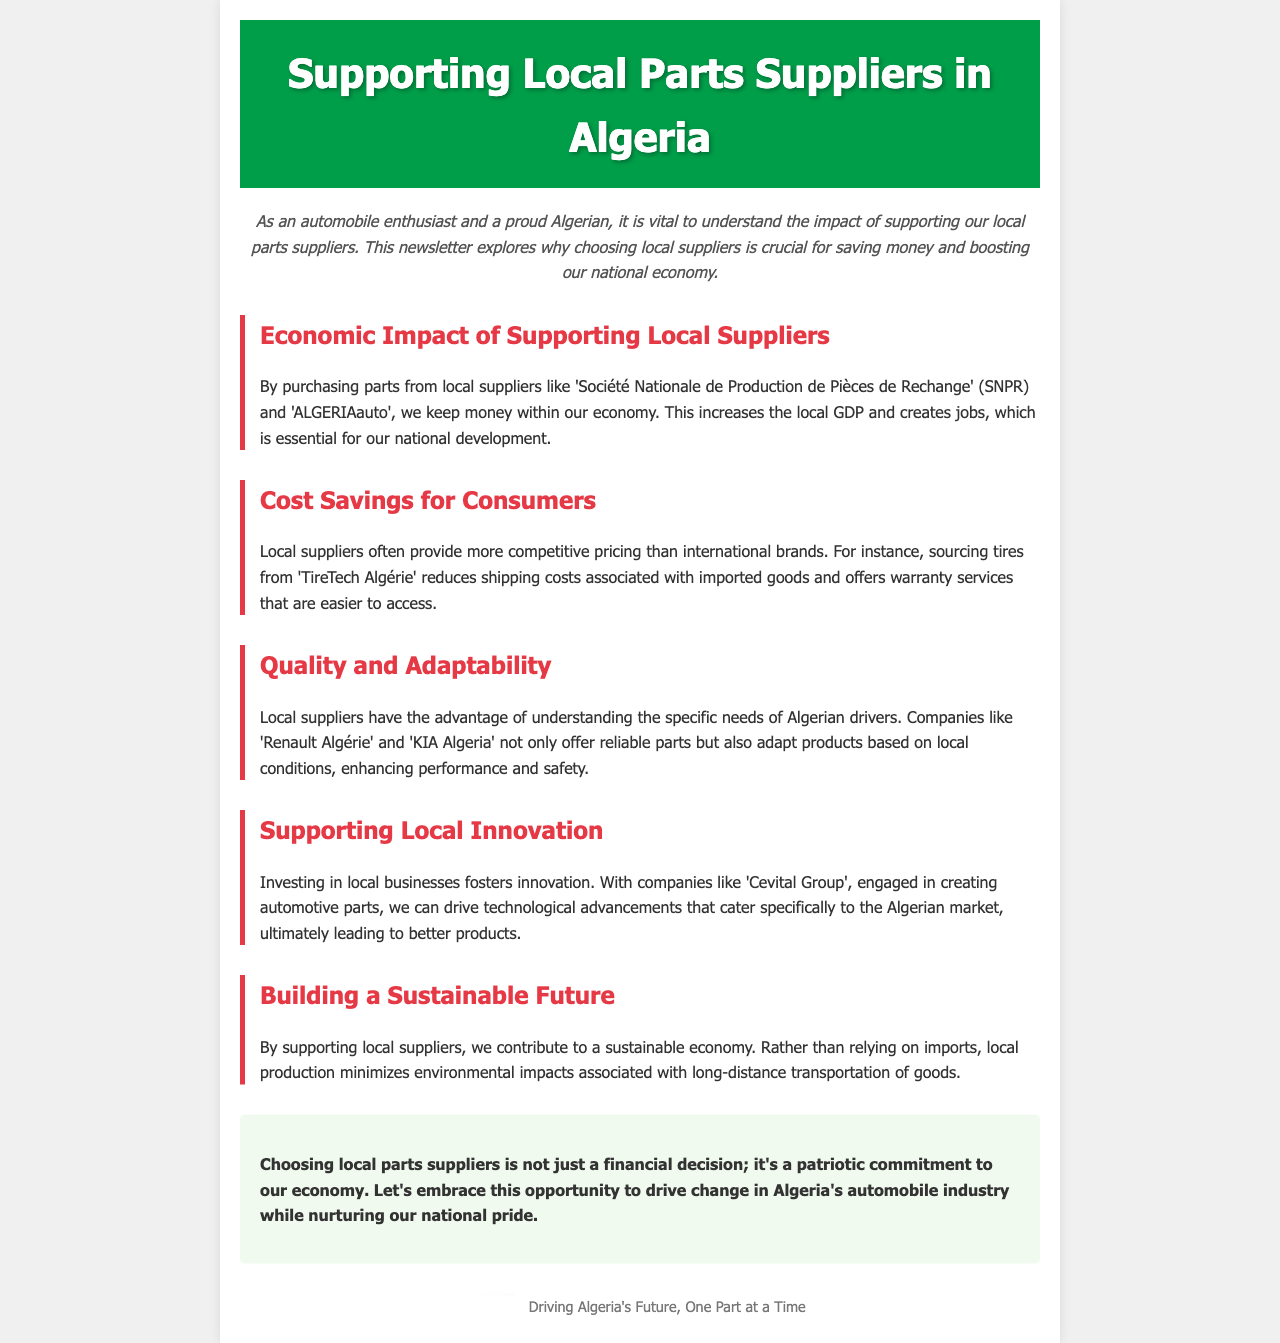What is the title of the newsletter? The title is found in the header of the document.
Answer: Supporting Local Parts Suppliers in Algeria Who are two local parts suppliers mentioned? The document provides examples in the economic impact section.
Answer: SNPR, ALGERIAauto What does supporting local suppliers increase? This information can be found in the economic impact discussion.
Answer: local GDP What is one example of a local supplier that offers competitive pricing? This detail is specified in the cost savings section.
Answer: TireTech Algérie What advantage do local suppliers have regarding product adaptability? This discussion is in the quality and adaptability section.
Answer: understanding specific needs Which company is mentioned as fostering local innovation? This is specified in the supporting local innovation section.
Answer: Cevital Group How does supporting local suppliers contribute to sustainability? This reasoning is explained in the building a sustainable future section.
Answer: minimizes environmental impacts What is the overarching theme of the newsletter's conclusion? The conclusion encapsulates the main idea discussed throughout the document.
Answer: patriotic commitment to our economy 